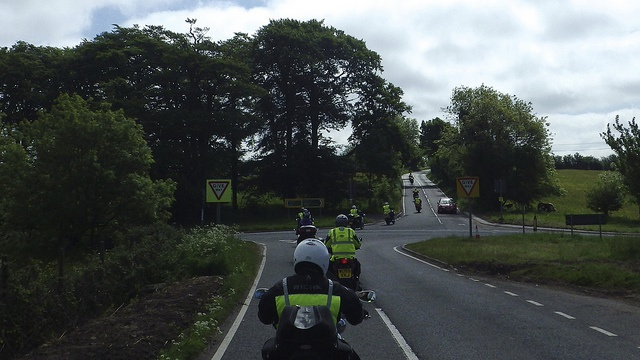Describe the objects in this image and their specific colors. I can see people in lightgray, black, gray, darkgreen, and darkblue tones, backpack in lightgray, black, gray, and darkgreen tones, people in lightgray, black, darkgreen, and gray tones, motorcycle in lightgray, black, darkgreen, maroon, and gray tones, and motorcycle in lightgray, black, gray, and darkgray tones in this image. 